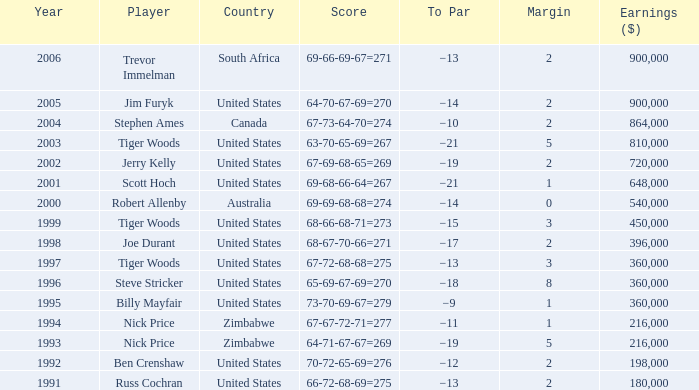Which margin has a state of united states, and a score of 63-70-65-69=267? 5.0. 